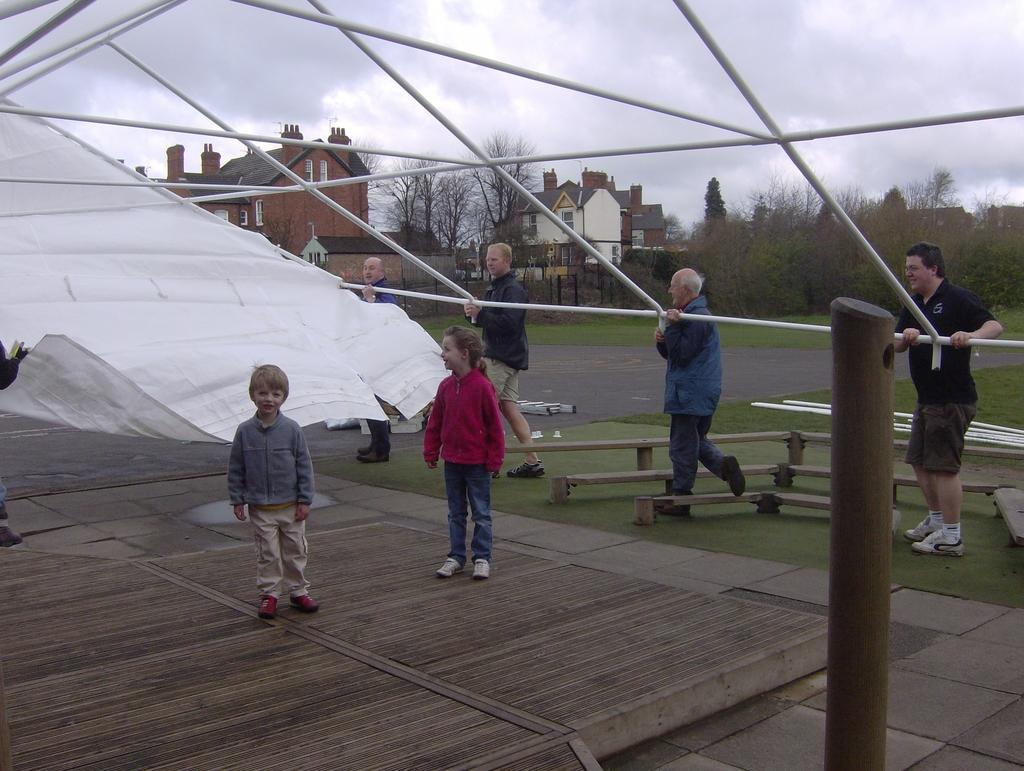What are the people in the image doing? The people in the image are standing on the grass. What are the people holding in the image? The people are holding a tent. What can be seen in the background of the image? There are buildings, trees, and the sky visible in the background of the image. What is the name of the harmony that the people are singing in the image? There is no indication in the image that the people are singing or that there is any harmony present. 